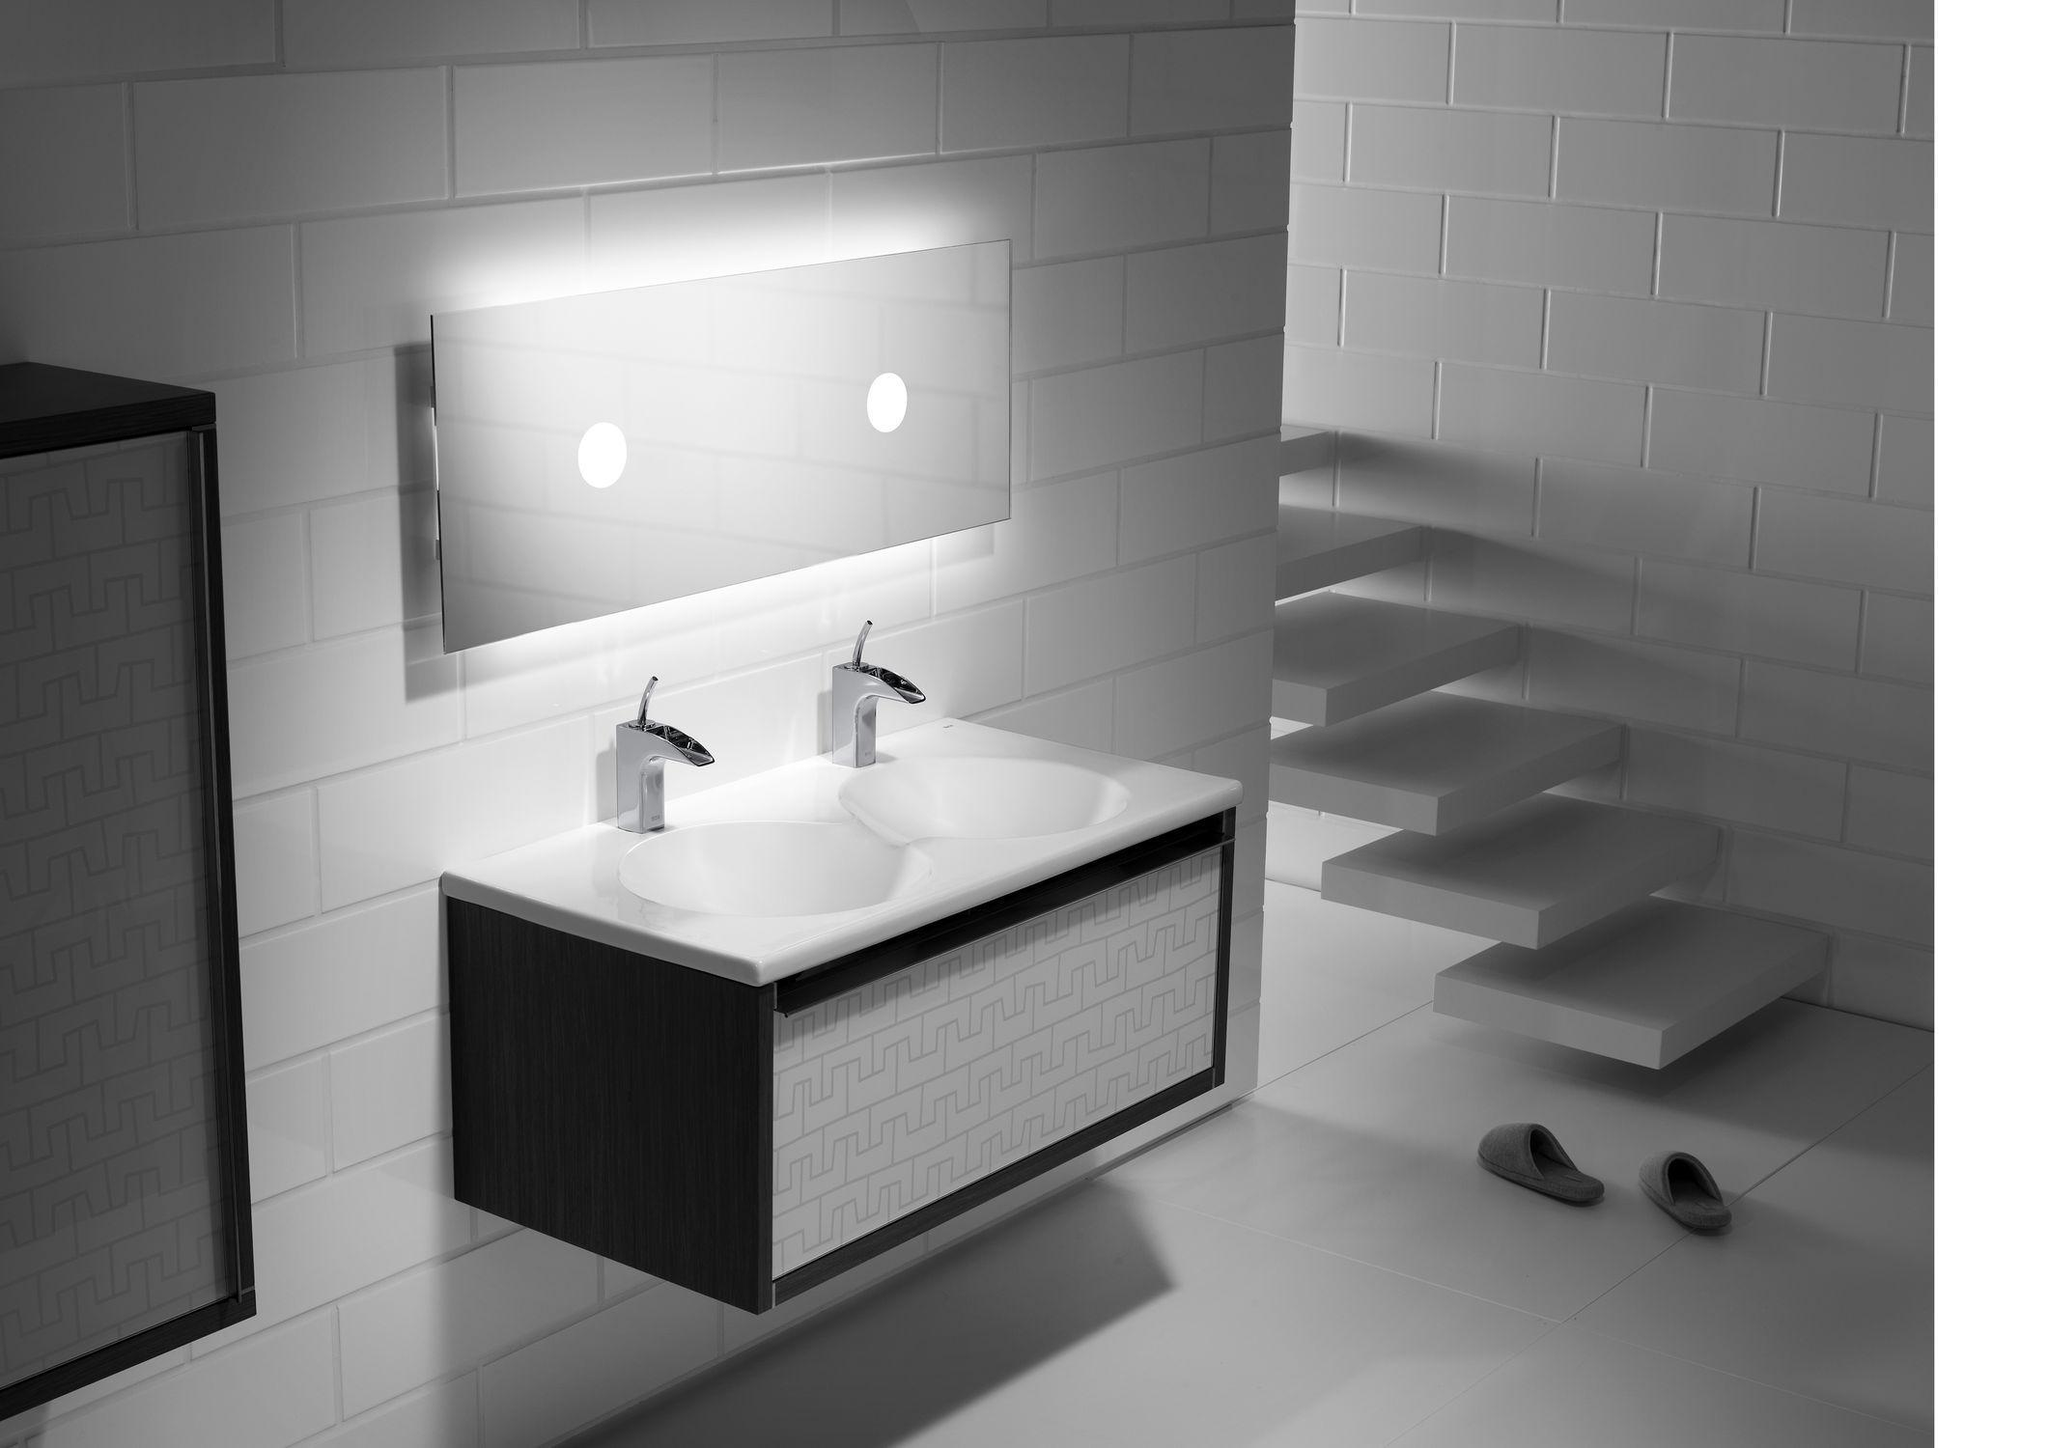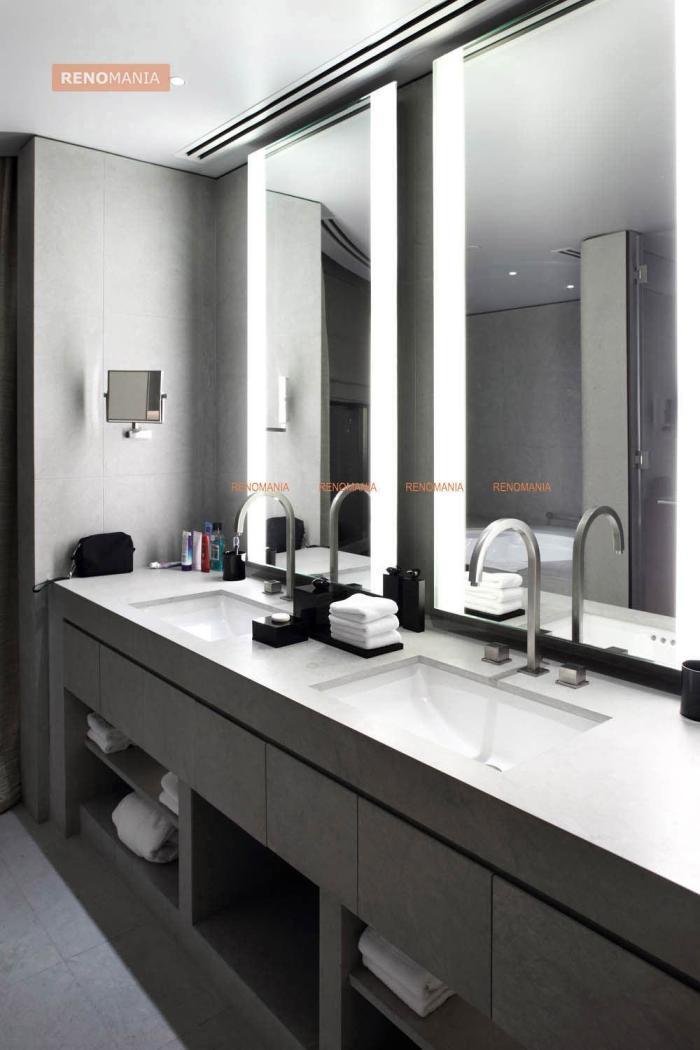The first image is the image on the left, the second image is the image on the right. Analyze the images presented: Is the assertion "A sink is in the shape of a cup." valid? Answer yes or no. No. 